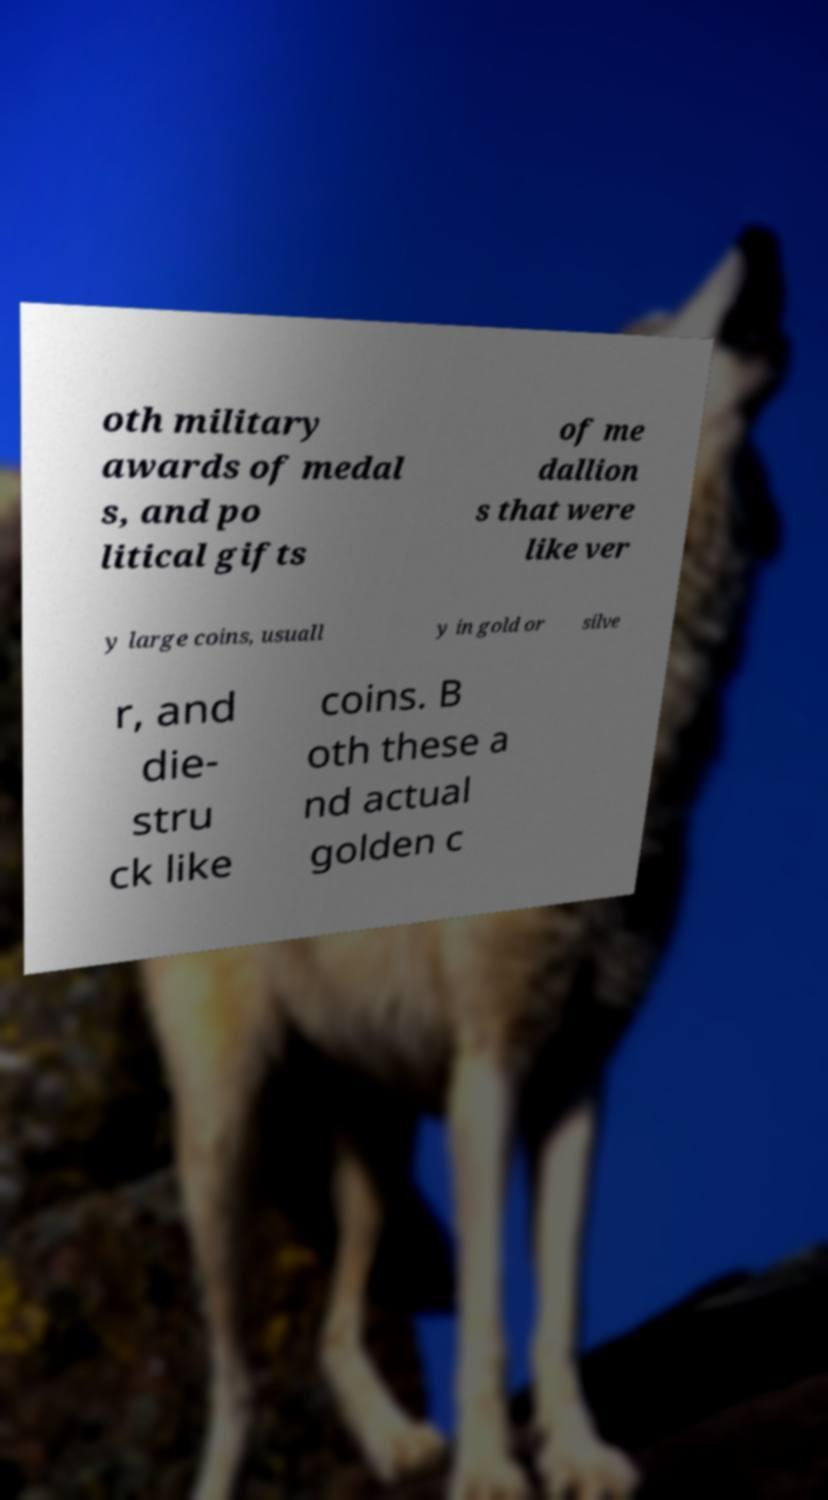Can you read and provide the text displayed in the image?This photo seems to have some interesting text. Can you extract and type it out for me? oth military awards of medal s, and po litical gifts of me dallion s that were like ver y large coins, usuall y in gold or silve r, and die- stru ck like coins. B oth these a nd actual golden c 